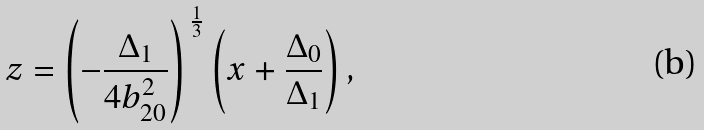<formula> <loc_0><loc_0><loc_500><loc_500>z = \left ( - \frac { \Delta _ { 1 } } { 4 b _ { 2 0 } ^ { 2 } } \right ) ^ { \, \frac { 1 } { 3 } } \left ( x + \frac { \Delta _ { 0 } } { \Delta _ { 1 } } \right ) ,</formula> 